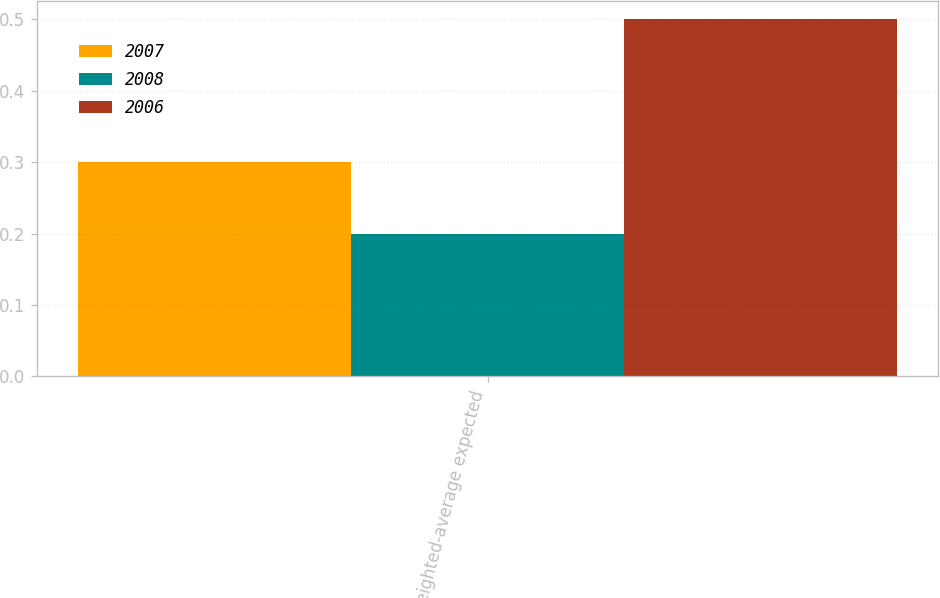<chart> <loc_0><loc_0><loc_500><loc_500><stacked_bar_chart><ecel><fcel>Weighted-average expected<nl><fcel>2007<fcel>0.3<nl><fcel>2008<fcel>0.2<nl><fcel>2006<fcel>0.5<nl></chart> 